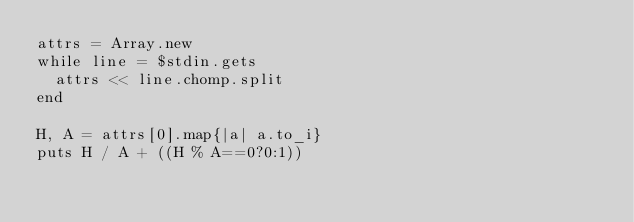<code> <loc_0><loc_0><loc_500><loc_500><_Ruby_>attrs = Array.new
while line = $stdin.gets
  attrs << line.chomp.split
end

H, A = attrs[0].map{|a| a.to_i}
puts H / A + ((H % A==0?0:1))</code> 